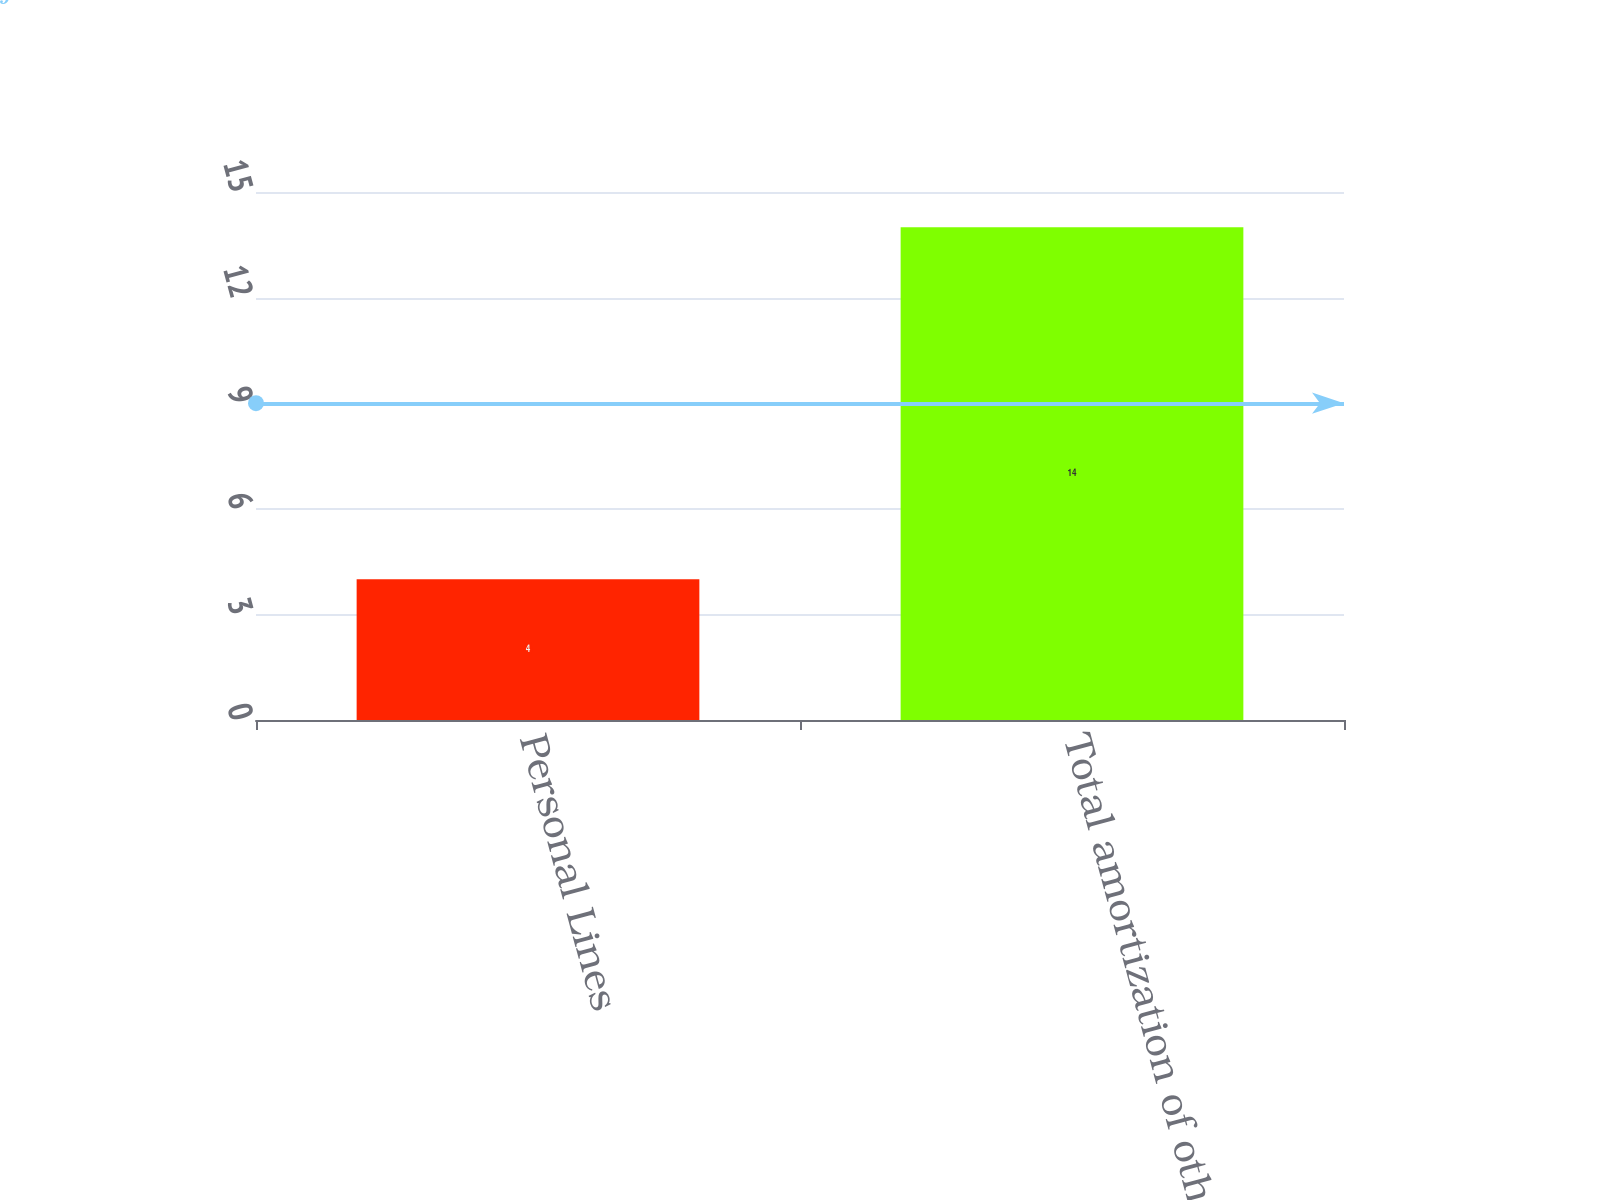Convert chart. <chart><loc_0><loc_0><loc_500><loc_500><bar_chart><fcel>Personal Lines<fcel>Total amortization of other<nl><fcel>4<fcel>14<nl></chart> 